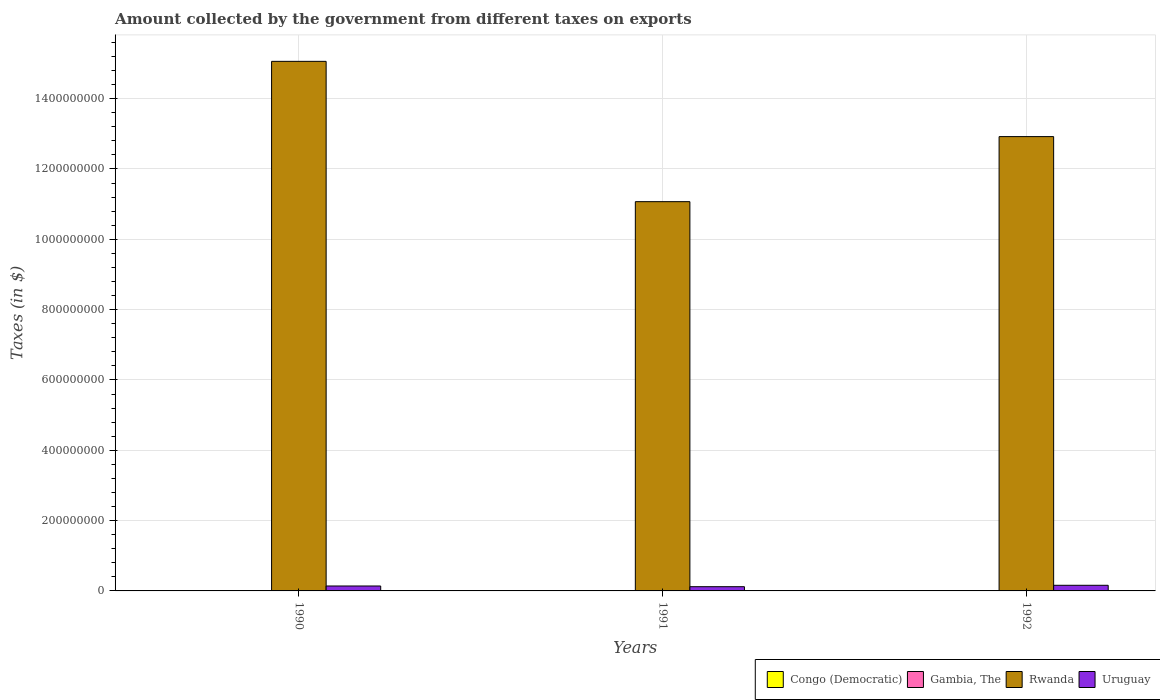How many bars are there on the 3rd tick from the right?
Provide a succinct answer. 4. In how many cases, is the number of bars for a given year not equal to the number of legend labels?
Ensure brevity in your answer.  0. What is the amount collected by the government from taxes on exports in Congo (Democratic) in 1990?
Keep it short and to the point. 0.09. Across all years, what is the minimum amount collected by the government from taxes on exports in Rwanda?
Give a very brief answer. 1.11e+09. What is the total amount collected by the government from taxes on exports in Congo (Democratic) in the graph?
Offer a very short reply. 35.56. What is the difference between the amount collected by the government from taxes on exports in Congo (Democratic) in 1990 and that in 1992?
Keep it short and to the point. -34.41. What is the difference between the amount collected by the government from taxes on exports in Congo (Democratic) in 1992 and the amount collected by the government from taxes on exports in Rwanda in 1990?
Offer a terse response. -1.51e+09. What is the average amount collected by the government from taxes on exports in Uruguay per year?
Your answer should be compact. 1.40e+07. In the year 1991, what is the difference between the amount collected by the government from taxes on exports in Uruguay and amount collected by the government from taxes on exports in Gambia, The?
Your answer should be compact. 1.15e+07. In how many years, is the amount collected by the government from taxes on exports in Rwanda greater than 360000000 $?
Make the answer very short. 3. What is the ratio of the amount collected by the government from taxes on exports in Uruguay in 1990 to that in 1991?
Offer a very short reply. 1.17. Is the difference between the amount collected by the government from taxes on exports in Uruguay in 1990 and 1992 greater than the difference between the amount collected by the government from taxes on exports in Gambia, The in 1990 and 1992?
Your answer should be very brief. No. What is the difference between the highest and the lowest amount collected by the government from taxes on exports in Rwanda?
Provide a succinct answer. 3.99e+08. Is the sum of the amount collected by the government from taxes on exports in Uruguay in 1990 and 1991 greater than the maximum amount collected by the government from taxes on exports in Gambia, The across all years?
Provide a short and direct response. Yes. What does the 2nd bar from the left in 1991 represents?
Offer a terse response. Gambia, The. What does the 1st bar from the right in 1990 represents?
Provide a short and direct response. Uruguay. Is it the case that in every year, the sum of the amount collected by the government from taxes on exports in Congo (Democratic) and amount collected by the government from taxes on exports in Gambia, The is greater than the amount collected by the government from taxes on exports in Rwanda?
Provide a short and direct response. No. Are all the bars in the graph horizontal?
Your answer should be compact. No. How many years are there in the graph?
Give a very brief answer. 3. What is the difference between two consecutive major ticks on the Y-axis?
Ensure brevity in your answer.  2.00e+08. Does the graph contain any zero values?
Your answer should be very brief. No. Does the graph contain grids?
Your answer should be compact. Yes. How many legend labels are there?
Give a very brief answer. 4. How are the legend labels stacked?
Offer a very short reply. Horizontal. What is the title of the graph?
Make the answer very short. Amount collected by the government from different taxes on exports. What is the label or title of the Y-axis?
Your answer should be very brief. Taxes (in $). What is the Taxes (in $) of Congo (Democratic) in 1990?
Keep it short and to the point. 0.09. What is the Taxes (in $) of Rwanda in 1990?
Offer a terse response. 1.51e+09. What is the Taxes (in $) in Uruguay in 1990?
Offer a terse response. 1.40e+07. What is the Taxes (in $) of Congo (Democratic) in 1991?
Your response must be concise. 0.98. What is the Taxes (in $) in Gambia, The in 1991?
Ensure brevity in your answer.  5.00e+05. What is the Taxes (in $) of Rwanda in 1991?
Offer a very short reply. 1.11e+09. What is the Taxes (in $) of Congo (Democratic) in 1992?
Make the answer very short. 34.5. What is the Taxes (in $) of Gambia, The in 1992?
Give a very brief answer. 3.20e+05. What is the Taxes (in $) in Rwanda in 1992?
Your answer should be very brief. 1.29e+09. What is the Taxes (in $) of Uruguay in 1992?
Keep it short and to the point. 1.60e+07. Across all years, what is the maximum Taxes (in $) in Congo (Democratic)?
Keep it short and to the point. 34.5. Across all years, what is the maximum Taxes (in $) of Gambia, The?
Give a very brief answer. 9.00e+05. Across all years, what is the maximum Taxes (in $) in Rwanda?
Give a very brief answer. 1.51e+09. Across all years, what is the maximum Taxes (in $) in Uruguay?
Provide a succinct answer. 1.60e+07. Across all years, what is the minimum Taxes (in $) of Congo (Democratic)?
Ensure brevity in your answer.  0.09. Across all years, what is the minimum Taxes (in $) in Rwanda?
Keep it short and to the point. 1.11e+09. What is the total Taxes (in $) of Congo (Democratic) in the graph?
Your response must be concise. 35.56. What is the total Taxes (in $) of Gambia, The in the graph?
Give a very brief answer. 1.72e+06. What is the total Taxes (in $) in Rwanda in the graph?
Give a very brief answer. 3.90e+09. What is the total Taxes (in $) of Uruguay in the graph?
Ensure brevity in your answer.  4.20e+07. What is the difference between the Taxes (in $) in Congo (Democratic) in 1990 and that in 1991?
Offer a very short reply. -0.89. What is the difference between the Taxes (in $) of Rwanda in 1990 and that in 1991?
Your response must be concise. 3.99e+08. What is the difference between the Taxes (in $) in Uruguay in 1990 and that in 1991?
Offer a terse response. 2.00e+06. What is the difference between the Taxes (in $) in Congo (Democratic) in 1990 and that in 1992?
Your answer should be very brief. -34.41. What is the difference between the Taxes (in $) of Gambia, The in 1990 and that in 1992?
Your answer should be compact. 5.80e+05. What is the difference between the Taxes (in $) of Rwanda in 1990 and that in 1992?
Provide a succinct answer. 2.14e+08. What is the difference between the Taxes (in $) of Congo (Democratic) in 1991 and that in 1992?
Make the answer very short. -33.52. What is the difference between the Taxes (in $) in Rwanda in 1991 and that in 1992?
Offer a terse response. -1.85e+08. What is the difference between the Taxes (in $) in Uruguay in 1991 and that in 1992?
Your answer should be very brief. -4.00e+06. What is the difference between the Taxes (in $) of Congo (Democratic) in 1990 and the Taxes (in $) of Gambia, The in 1991?
Offer a terse response. -5.00e+05. What is the difference between the Taxes (in $) in Congo (Democratic) in 1990 and the Taxes (in $) in Rwanda in 1991?
Offer a terse response. -1.11e+09. What is the difference between the Taxes (in $) of Congo (Democratic) in 1990 and the Taxes (in $) of Uruguay in 1991?
Your answer should be very brief. -1.20e+07. What is the difference between the Taxes (in $) of Gambia, The in 1990 and the Taxes (in $) of Rwanda in 1991?
Provide a succinct answer. -1.11e+09. What is the difference between the Taxes (in $) of Gambia, The in 1990 and the Taxes (in $) of Uruguay in 1991?
Keep it short and to the point. -1.11e+07. What is the difference between the Taxes (in $) of Rwanda in 1990 and the Taxes (in $) of Uruguay in 1991?
Your response must be concise. 1.49e+09. What is the difference between the Taxes (in $) in Congo (Democratic) in 1990 and the Taxes (in $) in Gambia, The in 1992?
Give a very brief answer. -3.20e+05. What is the difference between the Taxes (in $) in Congo (Democratic) in 1990 and the Taxes (in $) in Rwanda in 1992?
Keep it short and to the point. -1.29e+09. What is the difference between the Taxes (in $) of Congo (Democratic) in 1990 and the Taxes (in $) of Uruguay in 1992?
Offer a very short reply. -1.60e+07. What is the difference between the Taxes (in $) in Gambia, The in 1990 and the Taxes (in $) in Rwanda in 1992?
Your response must be concise. -1.29e+09. What is the difference between the Taxes (in $) of Gambia, The in 1990 and the Taxes (in $) of Uruguay in 1992?
Provide a short and direct response. -1.51e+07. What is the difference between the Taxes (in $) of Rwanda in 1990 and the Taxes (in $) of Uruguay in 1992?
Offer a terse response. 1.49e+09. What is the difference between the Taxes (in $) of Congo (Democratic) in 1991 and the Taxes (in $) of Gambia, The in 1992?
Provide a succinct answer. -3.20e+05. What is the difference between the Taxes (in $) in Congo (Democratic) in 1991 and the Taxes (in $) in Rwanda in 1992?
Your response must be concise. -1.29e+09. What is the difference between the Taxes (in $) in Congo (Democratic) in 1991 and the Taxes (in $) in Uruguay in 1992?
Make the answer very short. -1.60e+07. What is the difference between the Taxes (in $) in Gambia, The in 1991 and the Taxes (in $) in Rwanda in 1992?
Ensure brevity in your answer.  -1.29e+09. What is the difference between the Taxes (in $) of Gambia, The in 1991 and the Taxes (in $) of Uruguay in 1992?
Your response must be concise. -1.55e+07. What is the difference between the Taxes (in $) of Rwanda in 1991 and the Taxes (in $) of Uruguay in 1992?
Offer a very short reply. 1.09e+09. What is the average Taxes (in $) in Congo (Democratic) per year?
Make the answer very short. 11.85. What is the average Taxes (in $) of Gambia, The per year?
Provide a succinct answer. 5.73e+05. What is the average Taxes (in $) of Rwanda per year?
Your answer should be very brief. 1.30e+09. What is the average Taxes (in $) of Uruguay per year?
Give a very brief answer. 1.40e+07. In the year 1990, what is the difference between the Taxes (in $) in Congo (Democratic) and Taxes (in $) in Gambia, The?
Ensure brevity in your answer.  -9.00e+05. In the year 1990, what is the difference between the Taxes (in $) in Congo (Democratic) and Taxes (in $) in Rwanda?
Keep it short and to the point. -1.51e+09. In the year 1990, what is the difference between the Taxes (in $) in Congo (Democratic) and Taxes (in $) in Uruguay?
Offer a very short reply. -1.40e+07. In the year 1990, what is the difference between the Taxes (in $) in Gambia, The and Taxes (in $) in Rwanda?
Provide a short and direct response. -1.51e+09. In the year 1990, what is the difference between the Taxes (in $) in Gambia, The and Taxes (in $) in Uruguay?
Give a very brief answer. -1.31e+07. In the year 1990, what is the difference between the Taxes (in $) in Rwanda and Taxes (in $) in Uruguay?
Ensure brevity in your answer.  1.49e+09. In the year 1991, what is the difference between the Taxes (in $) in Congo (Democratic) and Taxes (in $) in Gambia, The?
Provide a succinct answer. -5.00e+05. In the year 1991, what is the difference between the Taxes (in $) of Congo (Democratic) and Taxes (in $) of Rwanda?
Give a very brief answer. -1.11e+09. In the year 1991, what is the difference between the Taxes (in $) of Congo (Democratic) and Taxes (in $) of Uruguay?
Offer a terse response. -1.20e+07. In the year 1991, what is the difference between the Taxes (in $) of Gambia, The and Taxes (in $) of Rwanda?
Offer a terse response. -1.11e+09. In the year 1991, what is the difference between the Taxes (in $) of Gambia, The and Taxes (in $) of Uruguay?
Keep it short and to the point. -1.15e+07. In the year 1991, what is the difference between the Taxes (in $) of Rwanda and Taxes (in $) of Uruguay?
Your answer should be very brief. 1.10e+09. In the year 1992, what is the difference between the Taxes (in $) of Congo (Democratic) and Taxes (in $) of Gambia, The?
Offer a terse response. -3.20e+05. In the year 1992, what is the difference between the Taxes (in $) of Congo (Democratic) and Taxes (in $) of Rwanda?
Your answer should be compact. -1.29e+09. In the year 1992, what is the difference between the Taxes (in $) in Congo (Democratic) and Taxes (in $) in Uruguay?
Your answer should be compact. -1.60e+07. In the year 1992, what is the difference between the Taxes (in $) in Gambia, The and Taxes (in $) in Rwanda?
Provide a succinct answer. -1.29e+09. In the year 1992, what is the difference between the Taxes (in $) of Gambia, The and Taxes (in $) of Uruguay?
Provide a succinct answer. -1.57e+07. In the year 1992, what is the difference between the Taxes (in $) of Rwanda and Taxes (in $) of Uruguay?
Give a very brief answer. 1.28e+09. What is the ratio of the Taxes (in $) of Congo (Democratic) in 1990 to that in 1991?
Your response must be concise. 0.09. What is the ratio of the Taxes (in $) in Gambia, The in 1990 to that in 1991?
Ensure brevity in your answer.  1.8. What is the ratio of the Taxes (in $) in Rwanda in 1990 to that in 1991?
Ensure brevity in your answer.  1.36. What is the ratio of the Taxes (in $) of Congo (Democratic) in 1990 to that in 1992?
Give a very brief answer. 0. What is the ratio of the Taxes (in $) of Gambia, The in 1990 to that in 1992?
Make the answer very short. 2.81. What is the ratio of the Taxes (in $) of Rwanda in 1990 to that in 1992?
Give a very brief answer. 1.17. What is the ratio of the Taxes (in $) of Congo (Democratic) in 1991 to that in 1992?
Your response must be concise. 0.03. What is the ratio of the Taxes (in $) of Gambia, The in 1991 to that in 1992?
Provide a short and direct response. 1.56. What is the ratio of the Taxes (in $) of Rwanda in 1991 to that in 1992?
Give a very brief answer. 0.86. What is the difference between the highest and the second highest Taxes (in $) in Congo (Democratic)?
Offer a terse response. 33.52. What is the difference between the highest and the second highest Taxes (in $) of Rwanda?
Your response must be concise. 2.14e+08. What is the difference between the highest and the second highest Taxes (in $) of Uruguay?
Ensure brevity in your answer.  2.00e+06. What is the difference between the highest and the lowest Taxes (in $) of Congo (Democratic)?
Provide a succinct answer. 34.41. What is the difference between the highest and the lowest Taxes (in $) of Gambia, The?
Make the answer very short. 5.80e+05. What is the difference between the highest and the lowest Taxes (in $) of Rwanda?
Your answer should be very brief. 3.99e+08. What is the difference between the highest and the lowest Taxes (in $) in Uruguay?
Keep it short and to the point. 4.00e+06. 